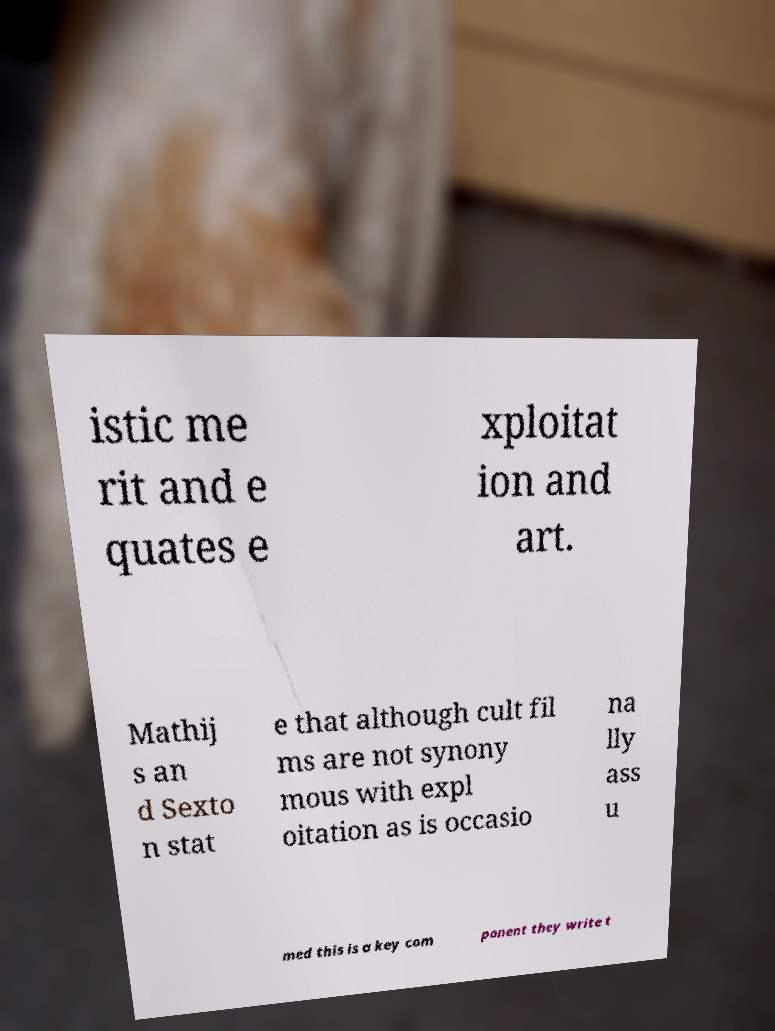For documentation purposes, I need the text within this image transcribed. Could you provide that? istic me rit and e quates e xploitat ion and art. Mathij s an d Sexto n stat e that although cult fil ms are not synony mous with expl oitation as is occasio na lly ass u med this is a key com ponent they write t 